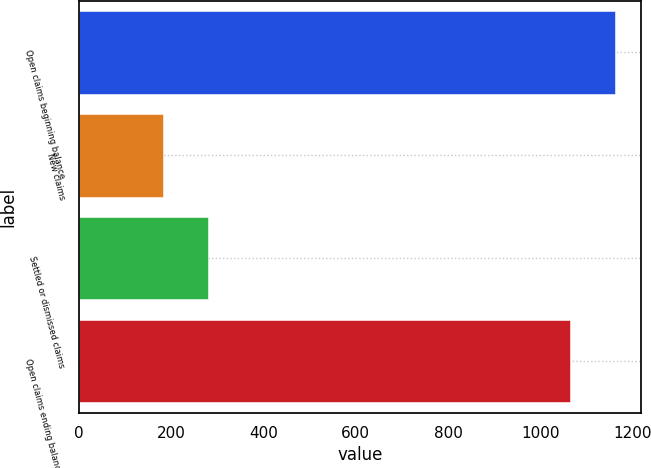Convert chart to OTSL. <chart><loc_0><loc_0><loc_500><loc_500><bar_chart><fcel>Open claims beginning balance<fcel>New claims<fcel>Settled or dismissed claims<fcel>Open claims ending balance at<nl><fcel>1160.7<fcel>183<fcel>278.7<fcel>1065<nl></chart> 